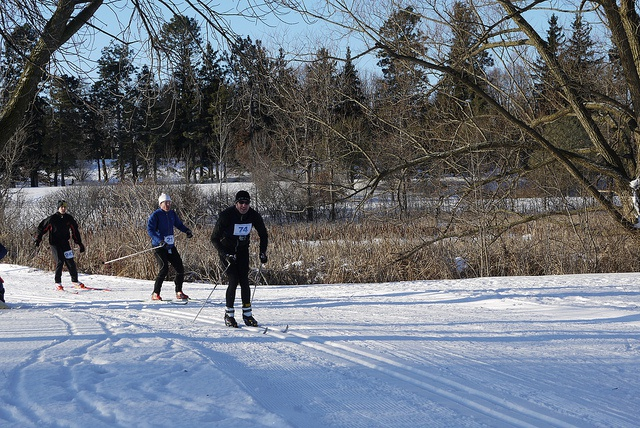Describe the objects in this image and their specific colors. I can see people in gray, black, and darkgray tones, people in gray, black, lightgray, and navy tones, people in gray, black, lightgray, and maroon tones, skis in gray, lightgray, and darkgray tones, and skis in gray, lightgray, lightpink, and darkgray tones in this image. 